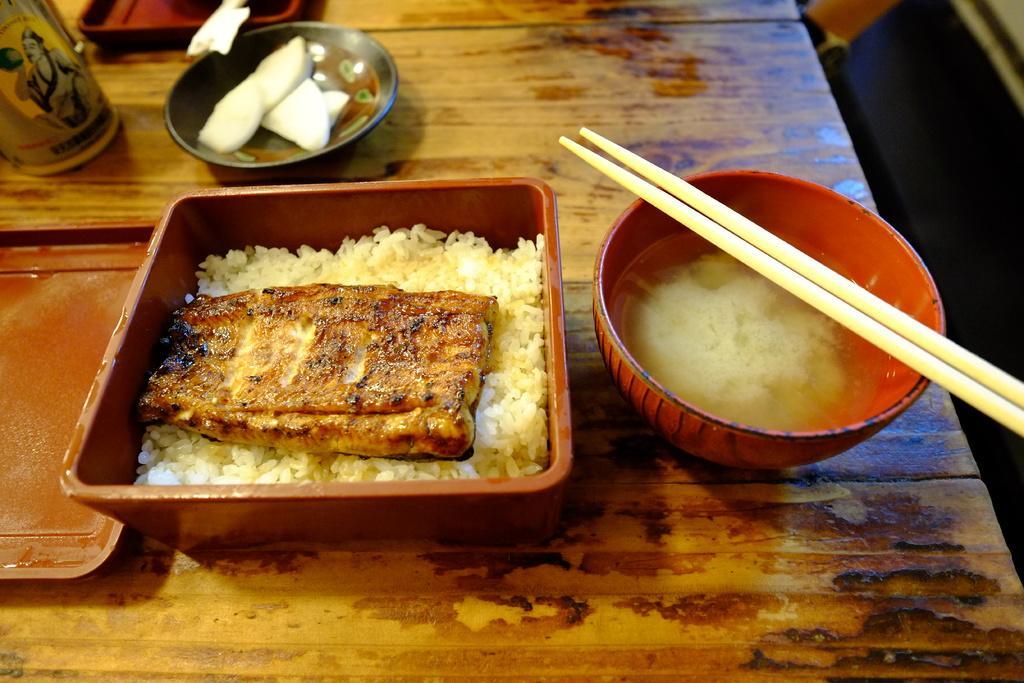Describe this image in one or two sentences. In this picture, this is a wooden table on the table there are bowl with soup on the bowl there is a chopsticks and on the table there are food items in boxes and on plate and also there are bottles. 